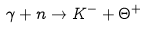<formula> <loc_0><loc_0><loc_500><loc_500>\gamma + n \to K ^ { - } + \Theta ^ { + }</formula> 